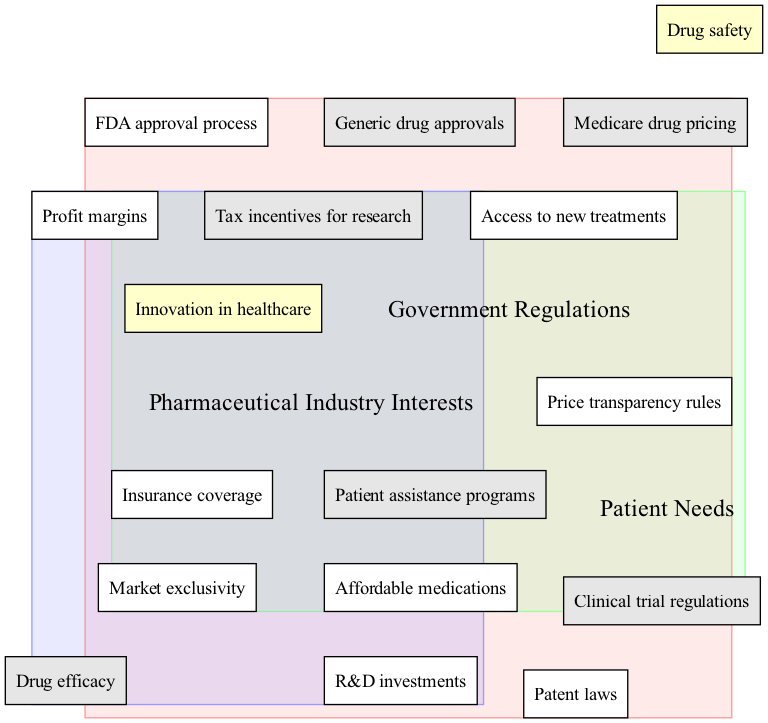What are the three main circles in the diagram? The diagram contains three main circles: Government Regulations, Patient Needs, and Pharmaceutical Industry Interests. This information can be found in the labels of the circles that outline the different categories involved in the Venn diagram.
Answer: Government Regulations, Patient Needs, Pharmaceutical Industry Interests How many elements are in the "Patient Needs" circle? The "Patient Needs" circle contains three elements: Affordable medications, Access to new treatments, and Insurance coverage. Counting the elements listed in the respective circle confirms this.
Answer: 3 What is one element found in the overlap between Government Regulations and Patient Needs? One element in the overlap between Government Regulations and Patient Needs is Medicare drug pricing. This information is directly reflected in the overlapping area where both circles intersect.
Answer: Medicare drug pricing Which elements represent the overlap between Government Regulations and the Pharmaceutical Industry? The elements in the overlap between Government Regulations and the Pharmaceutical Industry are Tax incentives for research and Clinical trial regulations. This can be verified by looking at the labeled area where these two circles intersect.
Answer: Tax incentives for research, Clinical trial regulations What is at the center of the diagram where all circles overlap? The center of the diagram, where all circles overlap, includes elements related to Drug safety and Innovation in healthcare. This is explicitly stated in the central part of the Venn diagram, highlighting common goals.
Answer: Drug safety, Innovation in healthcare How many total elements are in the "Pharmaceutical Industry Interests" circle? The "Pharmaceutical Industry Interests" circle contains three elements: R&D investments, Profit margins, and Market exclusivity. Counting these items gives the total number of elements in this circle.
Answer: 3 What kind of needs does the overlap between Patient Needs and Pharmaceutical Industry Interests address? The overlap between Patient Needs and Pharmaceutical Industry Interests addresses Patient assistance programs and Drug efficacy. These elements reflect the areas of concern that align both patient and industry goals.
Answer: Patient assistance programs, Drug efficacy Which circle represents regulations related to drug pricing? The Government Regulations circle represents regulations related to drug pricing. This can be understood as price transparency rules are part of government oversight concerning pharmaceuticals.
Answer: Government Regulations What incentive is shared between the Government and the Pharmaceutical Industry? A shared incentive between the Government and Pharmaceutical Industry is tax incentives for research. This is indicated in the overlap section where both interests align for mutual benefit.
Answer: Tax incentives for research 